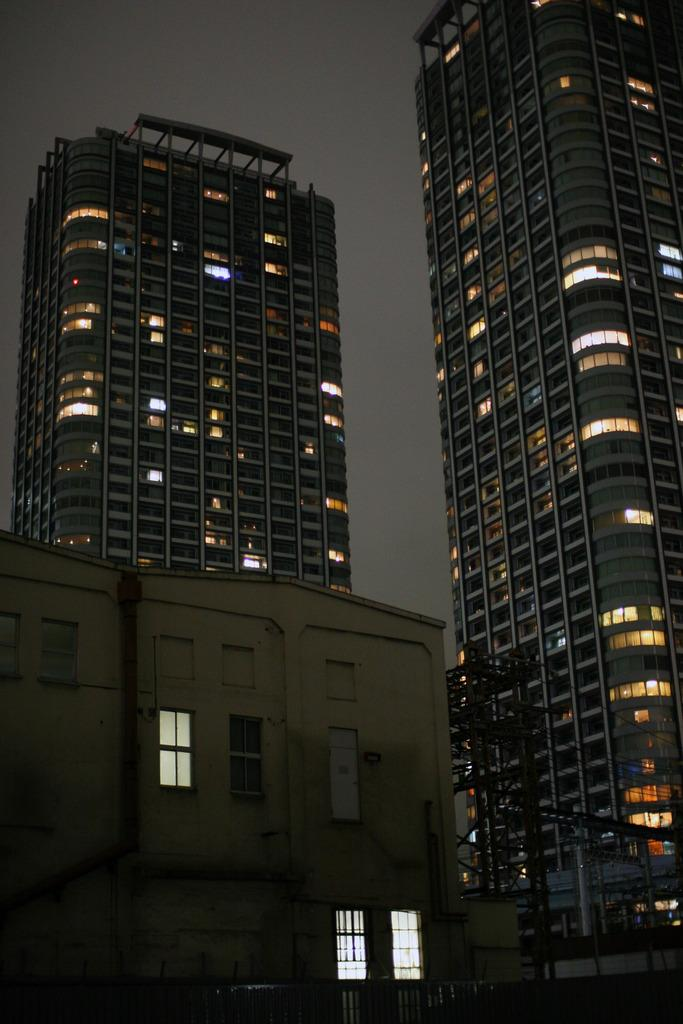What type of structures can be seen in the image? There are buildings in the image. Are there any illuminated objects in the image? Yes, there are lights in the image. What can be seen in the distance in the image? The sky is visible in the background of the image. How many chairs are hanging from the cobweb in the image? There are no chairs or cobwebs present in the image. 